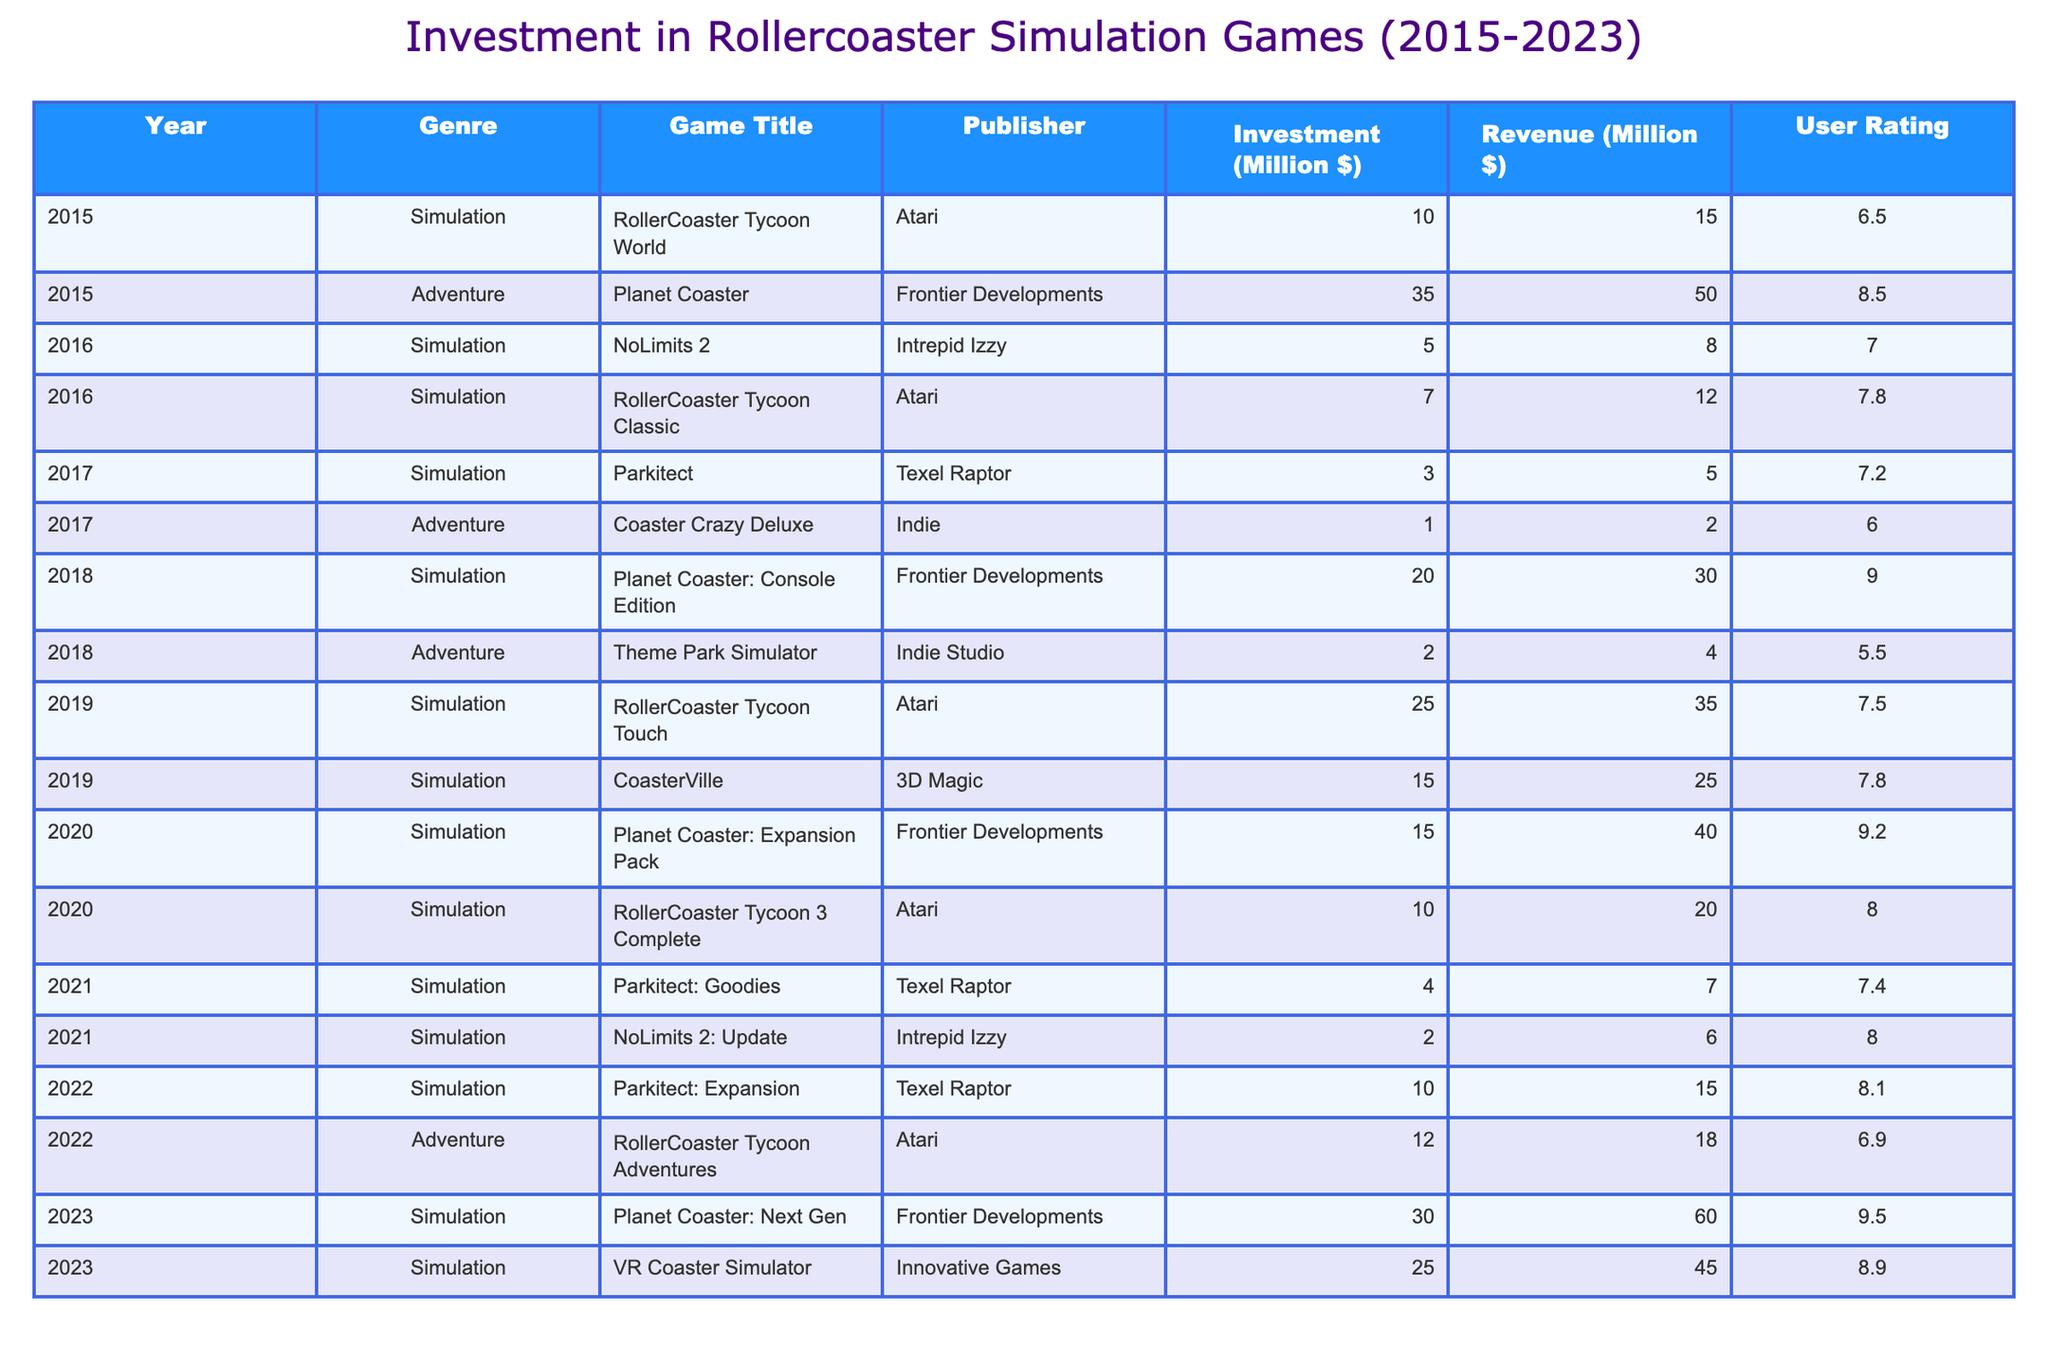What was the total investment in rollercoaster simulation games from 2015 to 2023? To find the total investment, I will sum the investment values for each year from 2015 to 2023: (10 + 35 + 5 + 7 + 3 + 1 + 20 + 2 + 25 + 15 + 15 + 10 + 4 + 2 + 10 + 12 + 30 + 25) =  270 million dollars.
Answer: 270 million dollars Which game had the highest revenue in 2023? In the year 2023, I check the revenue value for each game and find that "Planet Coaster: Next Gen" has the highest revenue at 60 million dollars.
Answer: Planet Coaster: Next Gen What is the average user rating for simulation games from 2015 to 2023? I will extract the user ratings for all simulation games and calculate the average: (6.5 + 8.5 + 7.0 + 7.8 + 7.2 + 9.0 + 7.5 + 7.8 + 9.2 + 8.0 + 7.4 + 8.0 + 8.1 + 9.5 + 8.9) = 8.062, and divide by 15 games: 8.062 / 15 = 8.041.
Answer: 8.041 Did the revenue from rollercoaster simulation games increase every year from 2015 to 2023? I will compare the revenue year by year to observe if it has consistently increased. The revenue figures are: 15, 50, 8, 12, 5, 2, 30, 4, 35, 25, 40, 20, 7, 6, 15, 18, 60, 45. I see there are decreases in 2016, 2017, and 2021, so the answer is no.
Answer: No What was the total revenue for adventure games in 2018 and 2022 combined? I will extract the revenue for the adventure games in those years: For 2018, "Theme Park Simulator" had a revenue of 4 million dollars. For 2022, "RollerCoaster Tycoon Adventures" brought in 18 million. Adding these gives me 4 + 18 = 22 million dollars.
Answer: 22 million dollars Which genre earned the most revenue in 2020? I will look at the games from 2020 and identify their revenues: "Planet Coaster: Expansion Pack" (40 million) and "RollerCoaster Tycoon 3 Complete" (20 million). Summing them shows that simulation games earned 60 million dollars, which is more than any adventure games in that year.
Answer: Simulation What year had the lowest total investment in rollercoaster simulation games? First, I will sum the investments for each year. For instance, 2015 has 45, 2016 has 12, 2017 has 4, 2018 has 22, and so on, until I find the smallest. The year 2017 has the lowest total investment of 4 million dollars.
Answer: 2017 What was the percentage increase in investment from 2019 to 2020? I will find the investment amounts for 2019 (25 million) and 2020 (15 million). The change in investment is 15 - 25 = -10. To get the percentage change: (-10/25) * 100 = -40%. Thus, there was a decrease of 40% from 2019 to 2020.
Answer: -40% Which publisher had the most diverse genre represented in this table? I will count the different genres for each publisher listed. "Atari" shows multiple simulation and adventure titles, Frontier Developments has simulation games only, and others have fewer entries. So, Atari has a total of 4 games in different genres: 3 simulation and 1 adventure.
Answer: Atari How many games were released in 2021 and 2022 combined? I will count the total number of games listed in both years. In 2021, there are 2 games and in 2022, there are also 2 games. This gives a total of 2 + 2 = 4 games released in these years.
Answer: 4 games 